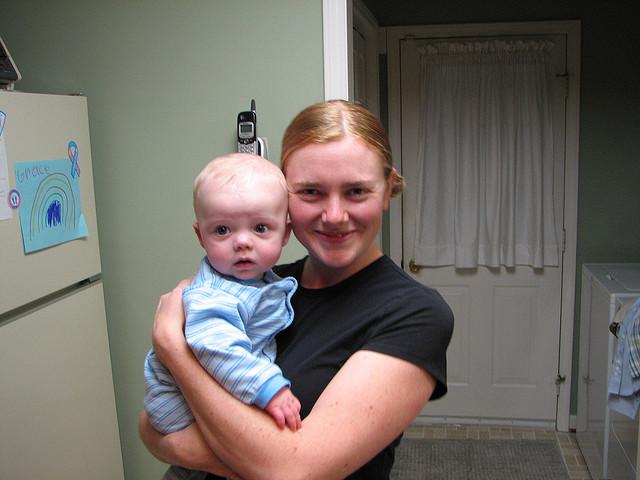What is the kid wearing?
Give a very brief answer. Onesie. Is the woman the baby's mother?
Quick response, please. Yes. Where is the child sitting?
Be succinct. Arms. Which room is this?
Answer briefly. Kitchen. Did this child draw the picture on the fridge?
Be succinct. No. Is the baby smiling?
Give a very brief answer. No. What is the girl doing?
Quick response, please. Holding baby. What color is the child's eyes?
Short answer required. Blue. Is the baby wearing a bib?
Be succinct. No. 